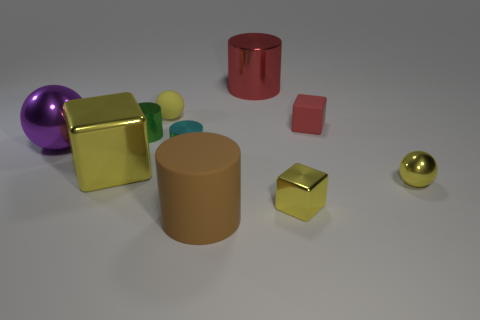Is there a green metallic sphere of the same size as the green metallic cylinder?
Give a very brief answer. No. How many things are either shiny balls that are to the left of the tiny yellow matte sphere or metal blocks on the right side of the large red metallic object?
Your answer should be compact. 2. There is a yellow sphere in front of the purple shiny ball; is it the same size as the yellow sphere that is behind the purple metallic thing?
Your response must be concise. Yes. Are there any cyan cylinders on the right side of the small cube that is behind the tiny green thing?
Ensure brevity in your answer.  No. There is a green object; what number of red objects are in front of it?
Keep it short and to the point. 0. How many other objects are there of the same color as the tiny rubber cube?
Your answer should be compact. 1. Is the number of small metallic objects on the left side of the cyan cylinder less than the number of cylinders in front of the large yellow block?
Offer a terse response. No. How many objects are big metal things that are left of the big yellow metal cube or brown matte balls?
Your response must be concise. 1. There is a yellow rubber thing; is it the same size as the yellow metallic thing that is left of the brown matte cylinder?
Ensure brevity in your answer.  No. What size is the other yellow metallic object that is the same shape as the large yellow object?
Provide a short and direct response. Small. 